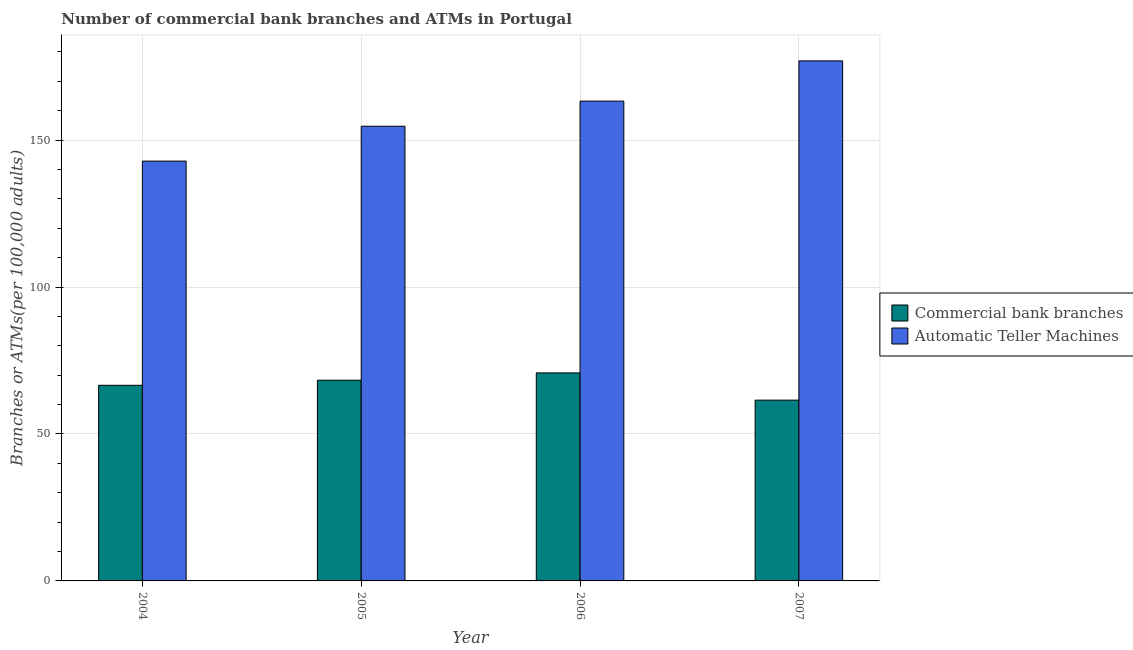How many different coloured bars are there?
Your answer should be very brief. 2. How many bars are there on the 3rd tick from the left?
Your response must be concise. 2. How many bars are there on the 2nd tick from the right?
Offer a very short reply. 2. What is the number of atms in 2004?
Ensure brevity in your answer.  142.84. Across all years, what is the maximum number of commercal bank branches?
Your answer should be compact. 70.78. Across all years, what is the minimum number of atms?
Your response must be concise. 142.84. In which year was the number of atms maximum?
Offer a terse response. 2007. In which year was the number of commercal bank branches minimum?
Provide a short and direct response. 2007. What is the total number of commercal bank branches in the graph?
Offer a very short reply. 267.14. What is the difference between the number of atms in 2005 and that in 2007?
Your answer should be very brief. -22.23. What is the difference between the number of commercal bank branches in 2005 and the number of atms in 2006?
Keep it short and to the point. -2.5. What is the average number of atms per year?
Offer a terse response. 159.44. In how many years, is the number of atms greater than 30?
Keep it short and to the point. 4. What is the ratio of the number of commercal bank branches in 2006 to that in 2007?
Your answer should be compact. 1.15. What is the difference between the highest and the second highest number of atms?
Your answer should be very brief. 13.68. What is the difference between the highest and the lowest number of atms?
Give a very brief answer. 34.1. In how many years, is the number of commercal bank branches greater than the average number of commercal bank branches taken over all years?
Provide a succinct answer. 2. Is the sum of the number of commercal bank branches in 2004 and 2006 greater than the maximum number of atms across all years?
Offer a very short reply. Yes. What does the 2nd bar from the left in 2005 represents?
Give a very brief answer. Automatic Teller Machines. What does the 2nd bar from the right in 2004 represents?
Offer a terse response. Commercial bank branches. How many bars are there?
Provide a short and direct response. 8. How many years are there in the graph?
Your answer should be very brief. 4. How many legend labels are there?
Give a very brief answer. 2. How are the legend labels stacked?
Your response must be concise. Vertical. What is the title of the graph?
Your answer should be compact. Number of commercial bank branches and ATMs in Portugal. Does "RDB nonconcessional" appear as one of the legend labels in the graph?
Your answer should be compact. No. What is the label or title of the X-axis?
Make the answer very short. Year. What is the label or title of the Y-axis?
Your answer should be compact. Branches or ATMs(per 100,0 adults). What is the Branches or ATMs(per 100,000 adults) in Commercial bank branches in 2004?
Ensure brevity in your answer.  66.56. What is the Branches or ATMs(per 100,000 adults) in Automatic Teller Machines in 2004?
Give a very brief answer. 142.84. What is the Branches or ATMs(per 100,000 adults) of Commercial bank branches in 2005?
Provide a succinct answer. 68.28. What is the Branches or ATMs(per 100,000 adults) of Automatic Teller Machines in 2005?
Make the answer very short. 154.71. What is the Branches or ATMs(per 100,000 adults) in Commercial bank branches in 2006?
Keep it short and to the point. 70.78. What is the Branches or ATMs(per 100,000 adults) of Automatic Teller Machines in 2006?
Make the answer very short. 163.26. What is the Branches or ATMs(per 100,000 adults) of Commercial bank branches in 2007?
Offer a terse response. 61.51. What is the Branches or ATMs(per 100,000 adults) of Automatic Teller Machines in 2007?
Give a very brief answer. 176.94. Across all years, what is the maximum Branches or ATMs(per 100,000 adults) of Commercial bank branches?
Your answer should be very brief. 70.78. Across all years, what is the maximum Branches or ATMs(per 100,000 adults) of Automatic Teller Machines?
Make the answer very short. 176.94. Across all years, what is the minimum Branches or ATMs(per 100,000 adults) in Commercial bank branches?
Provide a succinct answer. 61.51. Across all years, what is the minimum Branches or ATMs(per 100,000 adults) of Automatic Teller Machines?
Keep it short and to the point. 142.84. What is the total Branches or ATMs(per 100,000 adults) in Commercial bank branches in the graph?
Keep it short and to the point. 267.14. What is the total Branches or ATMs(per 100,000 adults) in Automatic Teller Machines in the graph?
Provide a short and direct response. 637.75. What is the difference between the Branches or ATMs(per 100,000 adults) in Commercial bank branches in 2004 and that in 2005?
Provide a short and direct response. -1.72. What is the difference between the Branches or ATMs(per 100,000 adults) of Automatic Teller Machines in 2004 and that in 2005?
Give a very brief answer. -11.86. What is the difference between the Branches or ATMs(per 100,000 adults) of Commercial bank branches in 2004 and that in 2006?
Your answer should be compact. -4.22. What is the difference between the Branches or ATMs(per 100,000 adults) in Automatic Teller Machines in 2004 and that in 2006?
Your answer should be very brief. -20.42. What is the difference between the Branches or ATMs(per 100,000 adults) of Commercial bank branches in 2004 and that in 2007?
Provide a short and direct response. 5.05. What is the difference between the Branches or ATMs(per 100,000 adults) of Automatic Teller Machines in 2004 and that in 2007?
Your answer should be very brief. -34.1. What is the difference between the Branches or ATMs(per 100,000 adults) of Commercial bank branches in 2005 and that in 2006?
Your response must be concise. -2.5. What is the difference between the Branches or ATMs(per 100,000 adults) in Automatic Teller Machines in 2005 and that in 2006?
Your answer should be very brief. -8.55. What is the difference between the Branches or ATMs(per 100,000 adults) in Commercial bank branches in 2005 and that in 2007?
Offer a terse response. 6.77. What is the difference between the Branches or ATMs(per 100,000 adults) in Automatic Teller Machines in 2005 and that in 2007?
Provide a succinct answer. -22.23. What is the difference between the Branches or ATMs(per 100,000 adults) of Commercial bank branches in 2006 and that in 2007?
Your answer should be compact. 9.27. What is the difference between the Branches or ATMs(per 100,000 adults) in Automatic Teller Machines in 2006 and that in 2007?
Offer a terse response. -13.68. What is the difference between the Branches or ATMs(per 100,000 adults) in Commercial bank branches in 2004 and the Branches or ATMs(per 100,000 adults) in Automatic Teller Machines in 2005?
Your response must be concise. -88.15. What is the difference between the Branches or ATMs(per 100,000 adults) in Commercial bank branches in 2004 and the Branches or ATMs(per 100,000 adults) in Automatic Teller Machines in 2006?
Provide a short and direct response. -96.7. What is the difference between the Branches or ATMs(per 100,000 adults) of Commercial bank branches in 2004 and the Branches or ATMs(per 100,000 adults) of Automatic Teller Machines in 2007?
Provide a succinct answer. -110.38. What is the difference between the Branches or ATMs(per 100,000 adults) in Commercial bank branches in 2005 and the Branches or ATMs(per 100,000 adults) in Automatic Teller Machines in 2006?
Make the answer very short. -94.97. What is the difference between the Branches or ATMs(per 100,000 adults) in Commercial bank branches in 2005 and the Branches or ATMs(per 100,000 adults) in Automatic Teller Machines in 2007?
Offer a terse response. -108.66. What is the difference between the Branches or ATMs(per 100,000 adults) of Commercial bank branches in 2006 and the Branches or ATMs(per 100,000 adults) of Automatic Teller Machines in 2007?
Your answer should be very brief. -106.16. What is the average Branches or ATMs(per 100,000 adults) in Commercial bank branches per year?
Offer a very short reply. 66.79. What is the average Branches or ATMs(per 100,000 adults) of Automatic Teller Machines per year?
Offer a terse response. 159.44. In the year 2004, what is the difference between the Branches or ATMs(per 100,000 adults) in Commercial bank branches and Branches or ATMs(per 100,000 adults) in Automatic Teller Machines?
Your answer should be compact. -76.28. In the year 2005, what is the difference between the Branches or ATMs(per 100,000 adults) of Commercial bank branches and Branches or ATMs(per 100,000 adults) of Automatic Teller Machines?
Your answer should be compact. -86.42. In the year 2006, what is the difference between the Branches or ATMs(per 100,000 adults) of Commercial bank branches and Branches or ATMs(per 100,000 adults) of Automatic Teller Machines?
Your answer should be very brief. -92.47. In the year 2007, what is the difference between the Branches or ATMs(per 100,000 adults) of Commercial bank branches and Branches or ATMs(per 100,000 adults) of Automatic Teller Machines?
Provide a short and direct response. -115.43. What is the ratio of the Branches or ATMs(per 100,000 adults) in Commercial bank branches in 2004 to that in 2005?
Ensure brevity in your answer.  0.97. What is the ratio of the Branches or ATMs(per 100,000 adults) in Automatic Teller Machines in 2004 to that in 2005?
Offer a terse response. 0.92. What is the ratio of the Branches or ATMs(per 100,000 adults) of Commercial bank branches in 2004 to that in 2006?
Your answer should be compact. 0.94. What is the ratio of the Branches or ATMs(per 100,000 adults) in Commercial bank branches in 2004 to that in 2007?
Keep it short and to the point. 1.08. What is the ratio of the Branches or ATMs(per 100,000 adults) of Automatic Teller Machines in 2004 to that in 2007?
Keep it short and to the point. 0.81. What is the ratio of the Branches or ATMs(per 100,000 adults) in Commercial bank branches in 2005 to that in 2006?
Ensure brevity in your answer.  0.96. What is the ratio of the Branches or ATMs(per 100,000 adults) in Automatic Teller Machines in 2005 to that in 2006?
Your answer should be compact. 0.95. What is the ratio of the Branches or ATMs(per 100,000 adults) of Commercial bank branches in 2005 to that in 2007?
Your answer should be very brief. 1.11. What is the ratio of the Branches or ATMs(per 100,000 adults) in Automatic Teller Machines in 2005 to that in 2007?
Your response must be concise. 0.87. What is the ratio of the Branches or ATMs(per 100,000 adults) in Commercial bank branches in 2006 to that in 2007?
Your response must be concise. 1.15. What is the ratio of the Branches or ATMs(per 100,000 adults) in Automatic Teller Machines in 2006 to that in 2007?
Offer a very short reply. 0.92. What is the difference between the highest and the second highest Branches or ATMs(per 100,000 adults) in Commercial bank branches?
Your answer should be compact. 2.5. What is the difference between the highest and the second highest Branches or ATMs(per 100,000 adults) of Automatic Teller Machines?
Your response must be concise. 13.68. What is the difference between the highest and the lowest Branches or ATMs(per 100,000 adults) in Commercial bank branches?
Your answer should be very brief. 9.27. What is the difference between the highest and the lowest Branches or ATMs(per 100,000 adults) of Automatic Teller Machines?
Give a very brief answer. 34.1. 